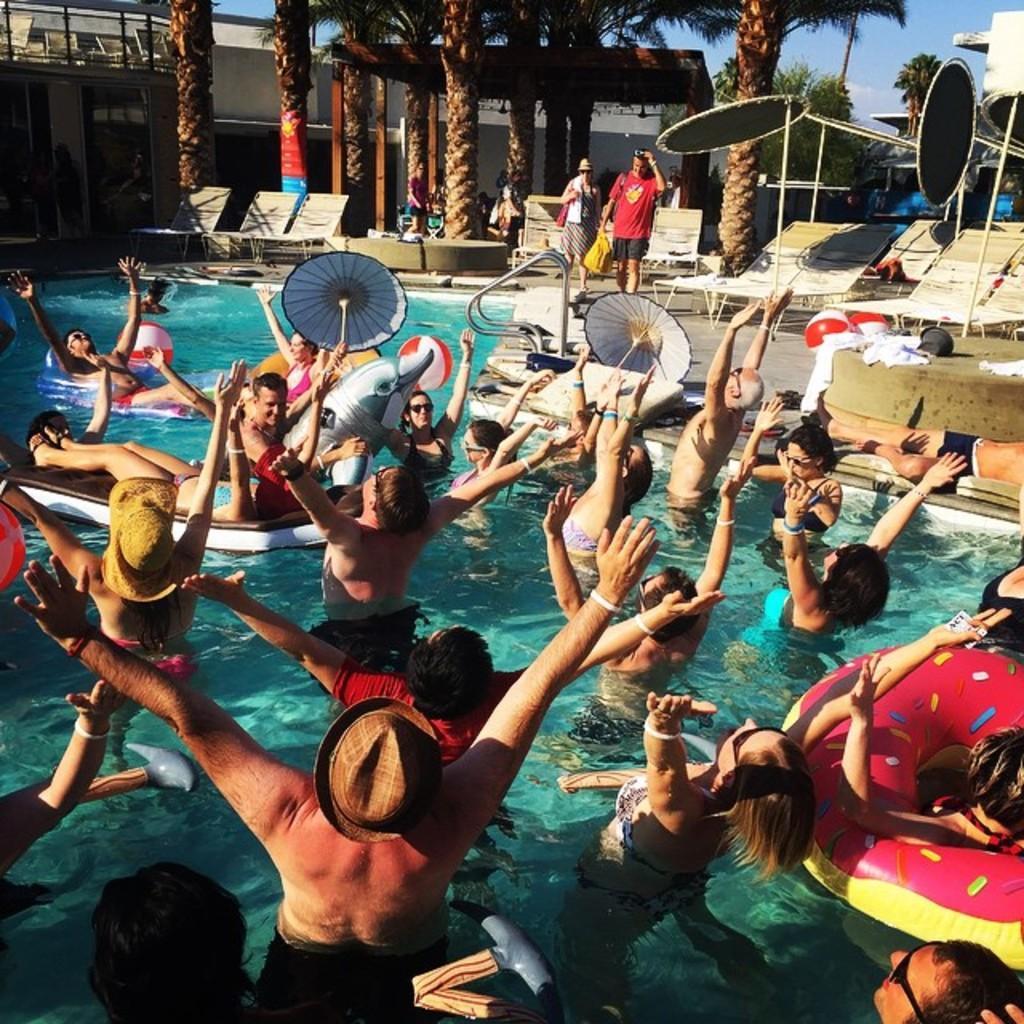Please provide a concise description of this image. In this image there is the sky towards the top of the image, there are trees towards the top of the image, there is a building towards the left of the image, there are chairs, there is a swimming pool towards the bottom of the image, there are persons in the swimming pool, there are umbrellas, there are women walking, they are holding an object, they are wearing bags, there is an object towards the right of the image. 